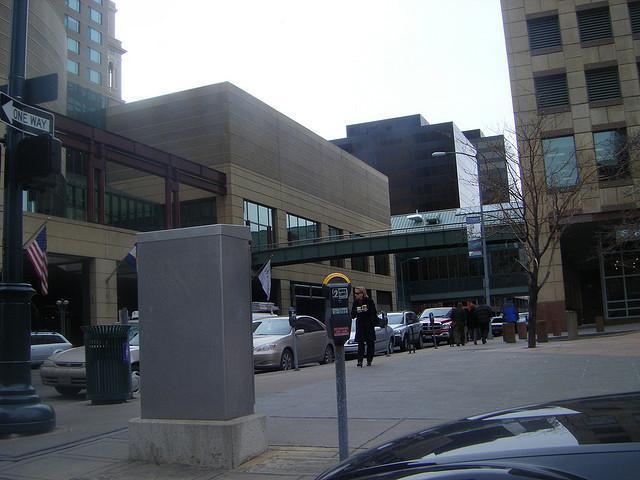How many cars can you see?
Give a very brief answer. 3. 